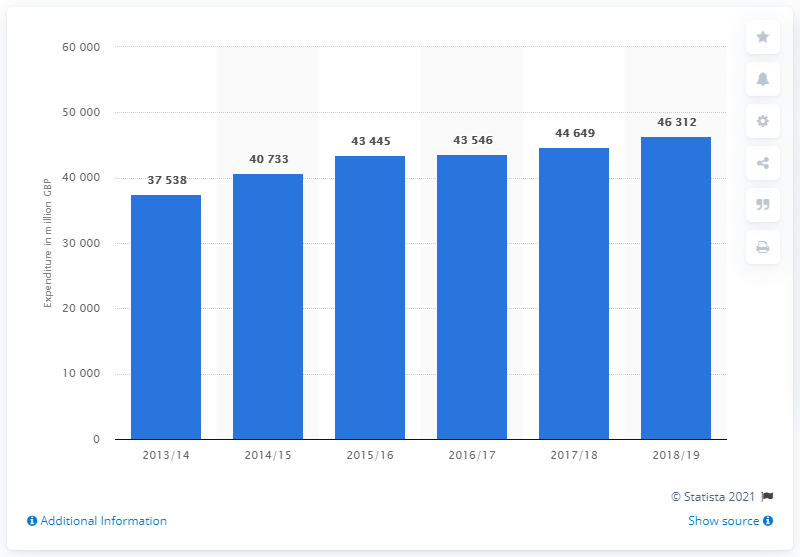Highlight a few significant elements in this photo. In the financial year 2018/19, the UK government spent approximately 46,312 million pounds on incapacity, disability, and injury benefits. 